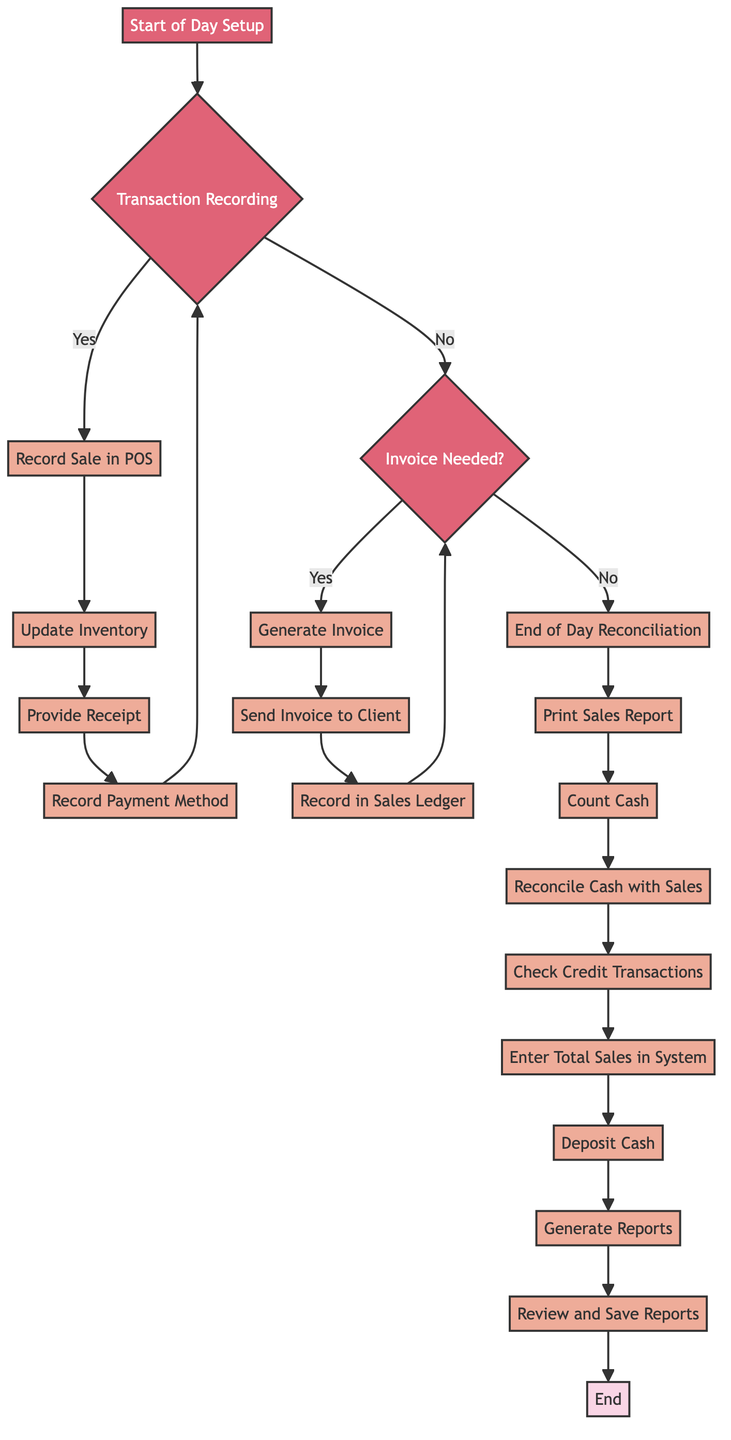What is the first step in the Daily Sales Accounting Flow? The flow starts with "Start of Day Setup," indicating the initial action that needs to be taken for the daily sales process.
Answer: Start of Day Setup How many steps are involved in Invoice Generation? The Invoice Generation section outlines four specific steps, which are essential for generating invoices as per client requests.
Answer: 4 What happens after 'Provide Receipt to Customer'? After providing a receipt to the customer, the next action is to "Record Payment Method (Cash/Credit)," indicating the sequence of transactions recorded in the process.
Answer: Record Payment Method Which step follows 'Count Cash in Register'? The step that directly follows "Count Cash in Register" is "Reconcile Cash with Sales Report," indicating the flow of activities during the end-of-day reconciliation process.
Answer: Reconcile Cash with Sales Report If an invoice is requested, what is the next step after 'Generate Invoice'? After generating an invoice, the following step is to "Print/Email Invoice to Client," indicating the process of delivering the invoice to the client.
Answer: Print/Email Invoice to Client What is the last step of the Daily Sales Accounting Flow? The final step in the flow diagram is labeled "End," which signifies the completion of the daily sales accounting activities.
Answer: End How many decision points are present in the flow? The flowchart includes two decision points: one regarding the recording of transactions and another pertaining to whether an invoice is needed, indicating points where a choice must be made.
Answer: 2 What does the 'Prepare for Next Day' step entail? This step comes after depositing cash and involves preparing for the subsequent business day, indicating readiness for future transactions.
Answer: Prepare for Next Day What is checked during the End of Day Reconciliation? The 'Check Credit Card Transactions' step is part of the reconciliation process, signifying a check of all transactions completed by the end of the day.
Answer: Check Credit Card Transactions 